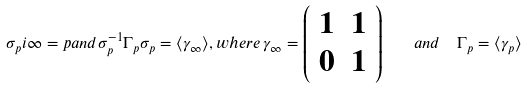<formula> <loc_0><loc_0><loc_500><loc_500>\sigma _ { p } i \infty = p a n d \sigma _ { p } ^ { - 1 } \Gamma _ { p } \sigma _ { p } = \langle \gamma _ { \infty } \rangle , w h e r e \, \gamma _ { \infty } = \left ( \begin{array} { c c c } 1 & 1 \\ 0 & 1 \end{array} \right ) \quad & a n d \quad \Gamma _ { p } = \langle \gamma _ { p } \rangle</formula> 